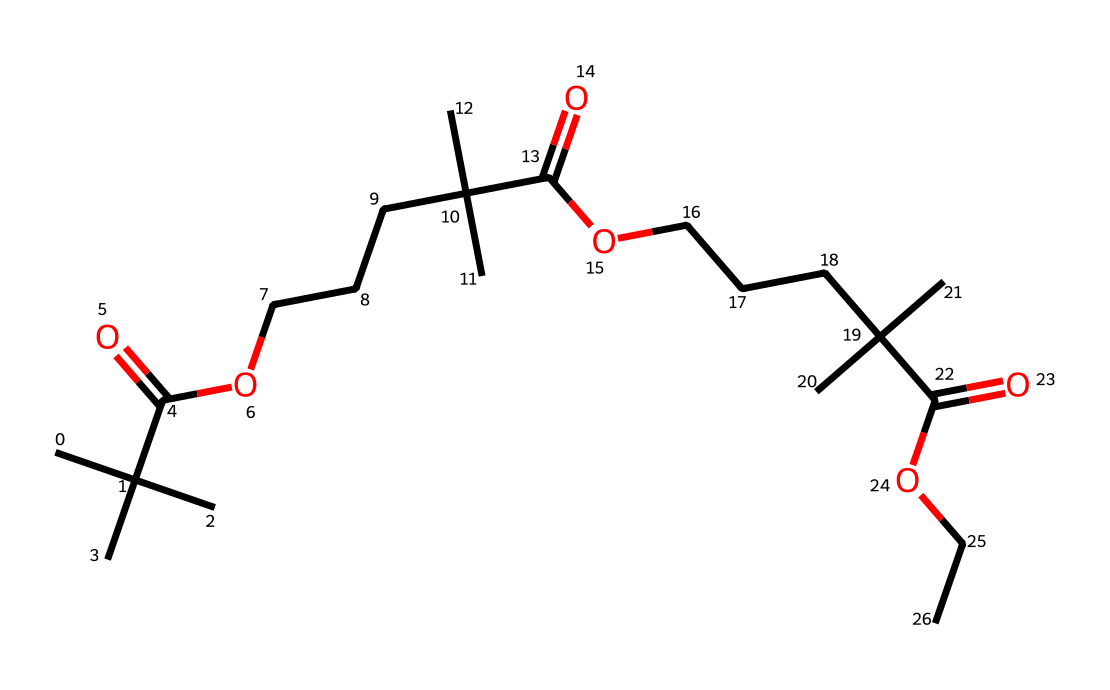what is the main functional group present in this compound? This chemical structure shows multiple carboxylic acid groups as indicated by the -COOH parts in the SMILES representation. Each segment of -C(=O)O represents one carboxylic acid functional group.
Answer: carboxylic acid how many carbon atoms are present in the molecule? The SMILES representation can be broken down by counting the carbon atoms associated with each alkyl group and the carboxylic acid groups. Each segment contains a number of carbon atoms, and adding them up gives a total of 27 carbon atoms.
Answer: 27 what type of polymer does this structure represent? This chemical structure is indicative of an acrylic polymer utilized in paints, as it contains long chains of carbon with functional groups that suggest it can form a film, typical of acrylic formulations.
Answer: acrylic polymer how many ester bonds are potentially formed in the structure? By analyzing the connections in the SMILES, it is noted that the carboxylic functionalities may interact with each other. However, esters are not indicated in this structure, leading to the conclusion that this specific representation does not exhibit ester bonds.
Answer: 0 what is the significance of the branching in this chemical structure? The branching seen in the structure suggests steric hindrance and can affect the physical properties of the paint, such as durability, viscosity, and drying time, often leading to improved performance in applications.
Answer: improves performance what characteristic makes this chemical suitable for use in paints? The presence of multiple functional groups and long aliphatic chains provided by the SMILES indicates that this compound can form a flexible, durable film upon drying, making it highly suitable for paint applications.
Answer: flexible, durable film 